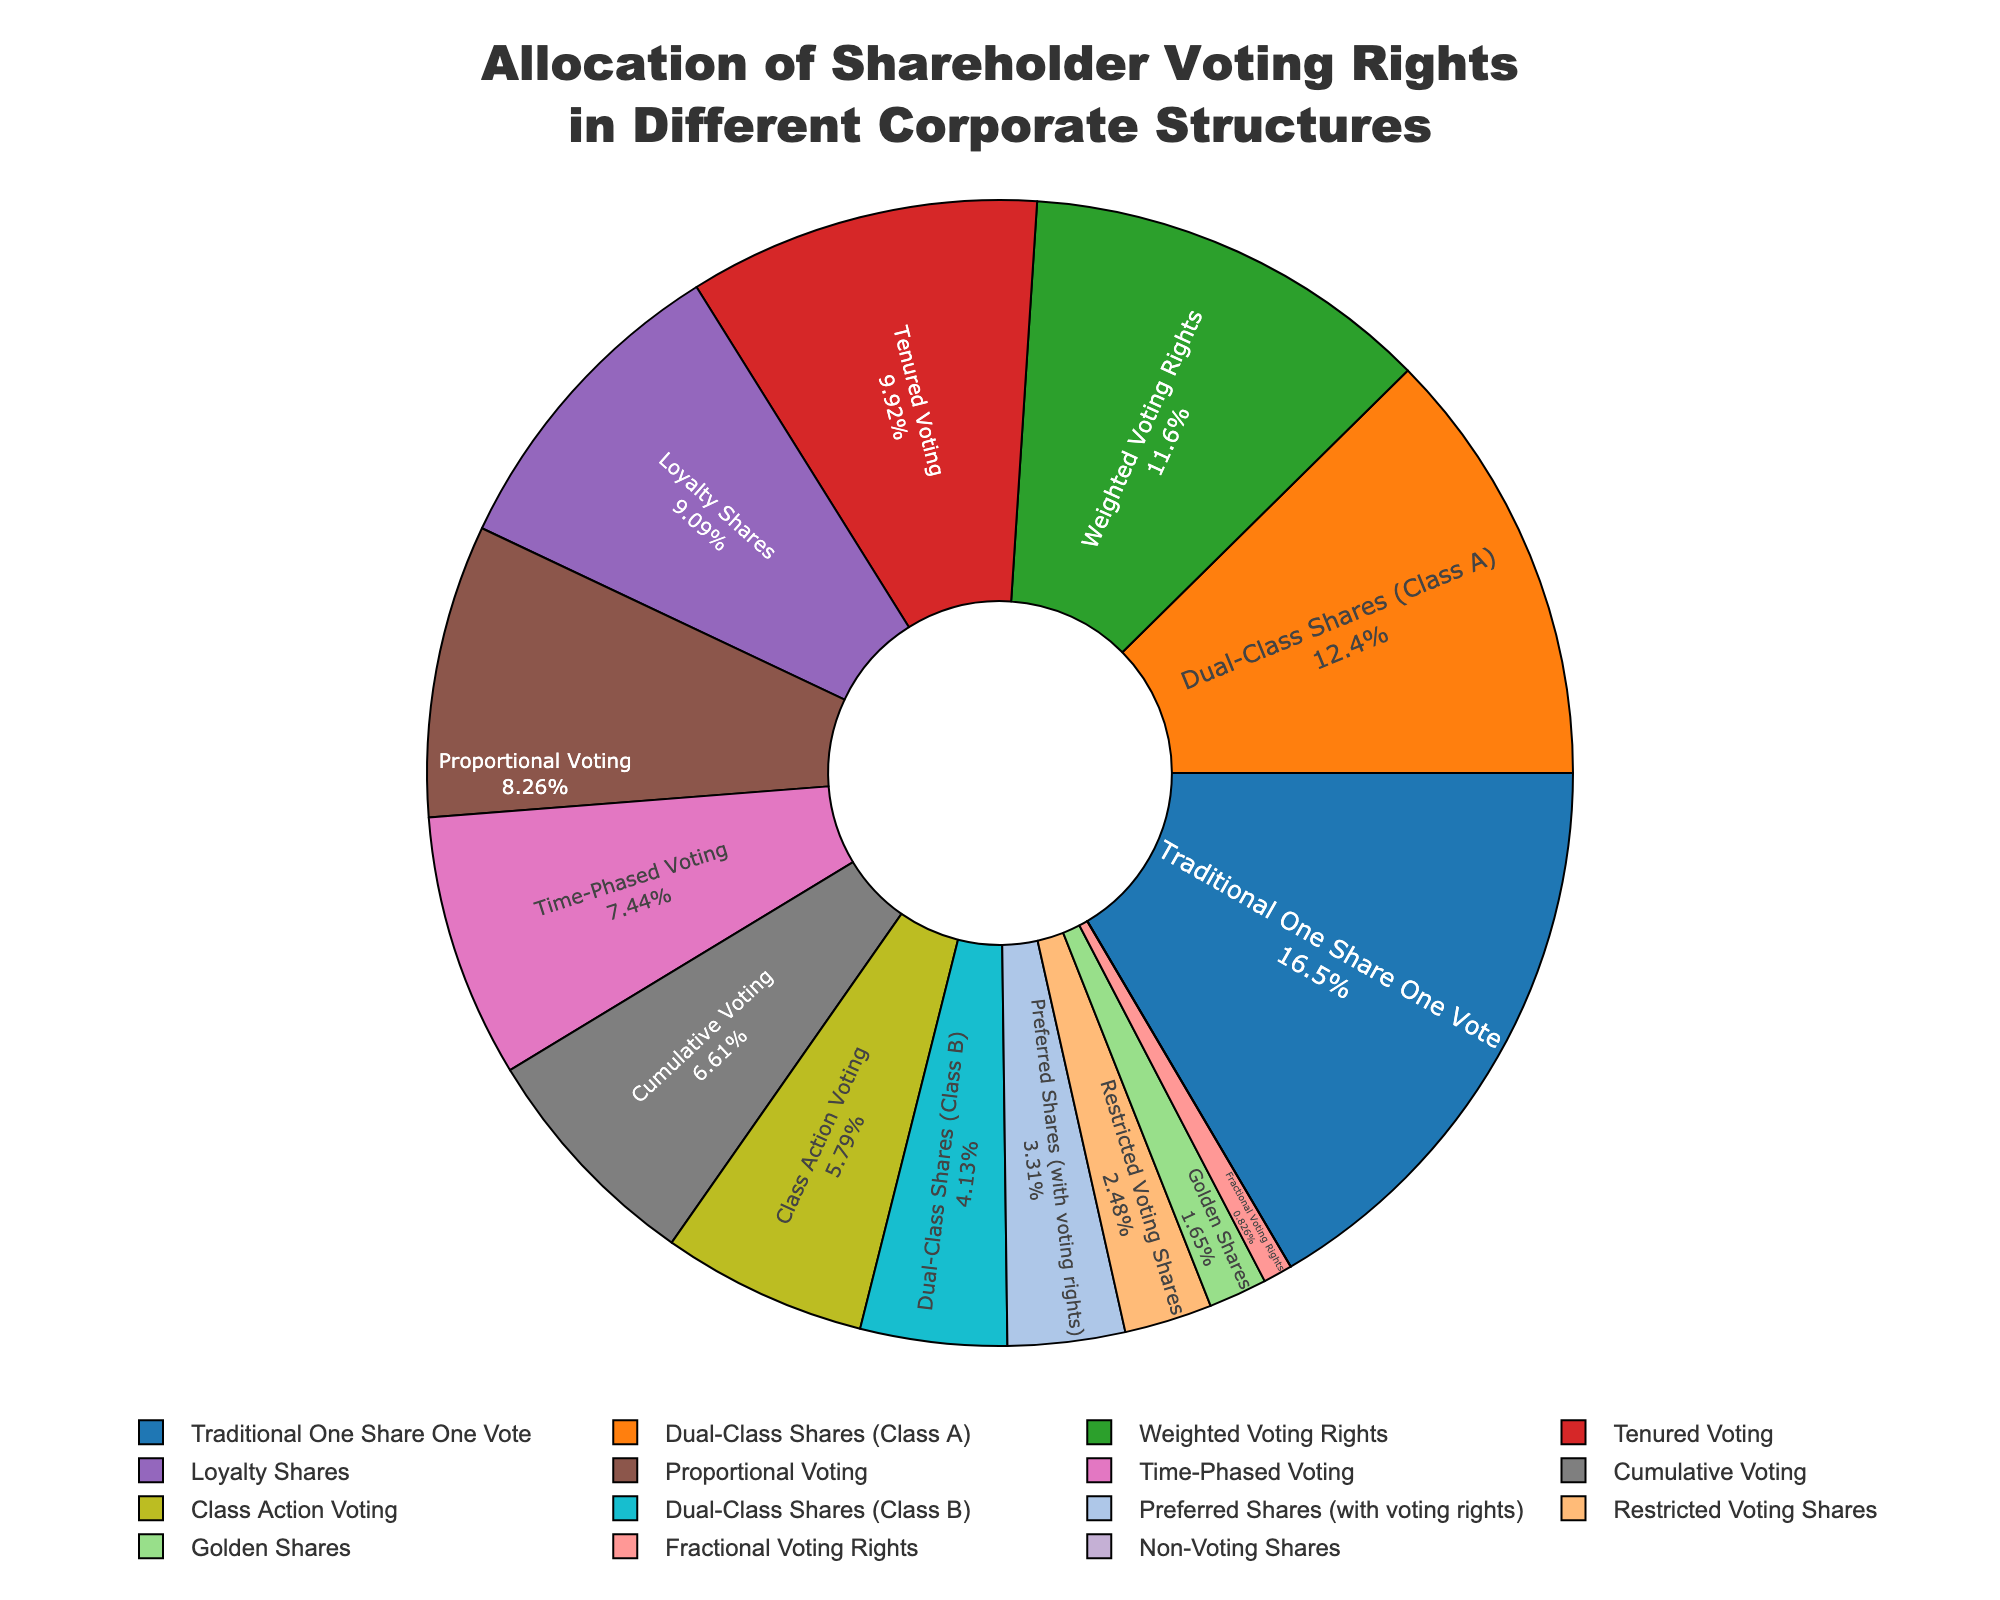What is the total percentage of voting rights allocation for Dual-Class Shares (Class A and Class B)? Dual-Class Shares (Class A) have 75% voting rights, and Dual-Class Shares (Class B) have 25%. Adding them together: 75% + 25% = 100%
Answer: 100% Which corporate structure has the highest allocation of voting rights? By examining the chart, we see that "Traditional One Share One Vote" has the highest allocation at 100%
Answer: Traditional One Share One Vote How much greater are the voting rights of Weighted Voting Rights compared to Cumulative Voting? Weighted Voting Rights have an allocation of 70%, while Cumulative Voting has 40%. The difference is 70% - 40% = 30%
Answer: 30% What fraction of the total voting rights does Preferred Shares (with voting rights) represent? Preferred Shares have a voting rights allocation of 20%. Sum the total voting rights allocations to find the denominator: 100 + 75 + 25 + 50 + 40 + 10 + 0 + 20 + 60 + 45 + 55 + 70 + 35 + 15 + 5 = 605. So, the fraction is 20/605, which simplifies to approximately 0.033
Answer: 0.033 Does Tenured Voting have more voting rights allocation than Proportional Voting? Tenured Voting has 60% allocation, while Proportional Voting has 50%. Since 60% > 50%, Tenured Voting has more
Answer: Yes Which corporate structures have the same or less voting rights allocation than Restricted Voting Shares? Restricted Voting Shares have 15%. The structures with the same or less are: *Golden Shares (10%)*, *Non-Voting Shares (0%)*, and *Fractional Voting Rights (5%)*
Answer: Golden Shares, Non-Voting Shares, Fractional Voting Rights What's the sum of the voting rights allocations for Time-Phased Voting, Loyalty Shares, and Class Action Voting? Time-Phased Voting has 45%, Loyalty Shares have 55%, and Class Action Voting has 35%. Adding them together: 45% + 55% + 35% = 135%
Answer: 135% If you combine the voting rights of Weighted Voting Rights and Traditional One Share One Vote, what percentage of the total do they represent? Weighted Voting Rights have 70%, and Traditional One Share One Vote has 100%. The combined is 70% + 100% = 170%. The total allocation is 605%, so the percentage of the total is (170 / 605) * 100 ≈ 28.1%
Answer: 28.1% Which corporate structure occupies the largest visual area in the chart? The largest visual area corresponds to the highest voting rights allocation, which is "Traditional One Share One Vote" at 100%
Answer: Traditional One Share One Vote 